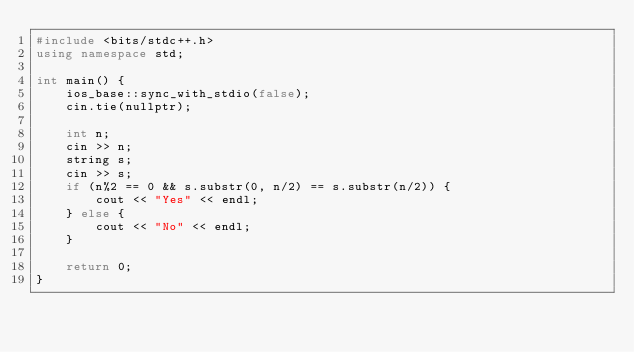Convert code to text. <code><loc_0><loc_0><loc_500><loc_500><_C++_>#include <bits/stdc++.h>
using namespace std;

int main() {
	ios_base::sync_with_stdio(false);
	cin.tie(nullptr);

	int n;
	cin >> n;
	string s;
	cin >> s;
	if (n%2 == 0 && s.substr(0, n/2) == s.substr(n/2)) {
		cout << "Yes" << endl;
	} else {
		cout << "No" << endl;
	}

	return 0;
}

</code> 